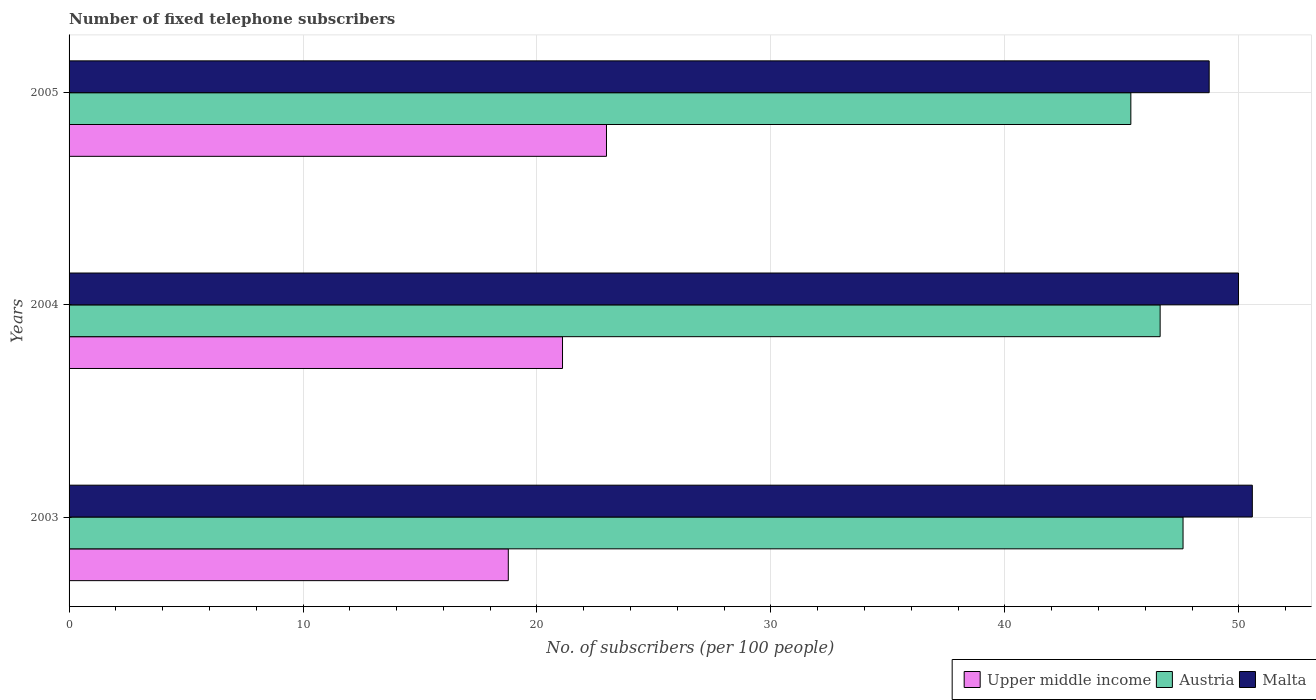How many different coloured bars are there?
Give a very brief answer. 3. How many bars are there on the 1st tick from the top?
Provide a short and direct response. 3. How many bars are there on the 1st tick from the bottom?
Your response must be concise. 3. What is the label of the 3rd group of bars from the top?
Offer a very short reply. 2003. In how many cases, is the number of bars for a given year not equal to the number of legend labels?
Keep it short and to the point. 0. What is the number of fixed telephone subscribers in Austria in 2005?
Your answer should be very brief. 45.38. Across all years, what is the maximum number of fixed telephone subscribers in Upper middle income?
Your answer should be very brief. 22.97. Across all years, what is the minimum number of fixed telephone subscribers in Upper middle income?
Your answer should be very brief. 18.77. In which year was the number of fixed telephone subscribers in Malta maximum?
Your response must be concise. 2003. In which year was the number of fixed telephone subscribers in Upper middle income minimum?
Ensure brevity in your answer.  2003. What is the total number of fixed telephone subscribers in Malta in the graph?
Your response must be concise. 149.3. What is the difference between the number of fixed telephone subscribers in Upper middle income in 2003 and that in 2004?
Offer a very short reply. -2.32. What is the difference between the number of fixed telephone subscribers in Austria in 2004 and the number of fixed telephone subscribers in Upper middle income in 2003?
Your answer should be very brief. 27.86. What is the average number of fixed telephone subscribers in Upper middle income per year?
Offer a terse response. 20.95. In the year 2003, what is the difference between the number of fixed telephone subscribers in Upper middle income and number of fixed telephone subscribers in Austria?
Give a very brief answer. -28.84. In how many years, is the number of fixed telephone subscribers in Upper middle income greater than 50 ?
Your response must be concise. 0. What is the ratio of the number of fixed telephone subscribers in Malta in 2003 to that in 2005?
Ensure brevity in your answer.  1.04. Is the number of fixed telephone subscribers in Malta in 2003 less than that in 2005?
Provide a short and direct response. No. Is the difference between the number of fixed telephone subscribers in Upper middle income in 2004 and 2005 greater than the difference between the number of fixed telephone subscribers in Austria in 2004 and 2005?
Give a very brief answer. No. What is the difference between the highest and the second highest number of fixed telephone subscribers in Austria?
Ensure brevity in your answer.  0.98. What is the difference between the highest and the lowest number of fixed telephone subscribers in Austria?
Ensure brevity in your answer.  2.23. What does the 2nd bar from the top in 2004 represents?
Ensure brevity in your answer.  Austria. What does the 1st bar from the bottom in 2004 represents?
Your response must be concise. Upper middle income. How many bars are there?
Offer a terse response. 9. How many years are there in the graph?
Ensure brevity in your answer.  3. What is the difference between two consecutive major ticks on the X-axis?
Offer a very short reply. 10. Does the graph contain any zero values?
Your answer should be very brief. No. Where does the legend appear in the graph?
Your response must be concise. Bottom right. How many legend labels are there?
Offer a terse response. 3. What is the title of the graph?
Provide a short and direct response. Number of fixed telephone subscribers. Does "European Union" appear as one of the legend labels in the graph?
Provide a short and direct response. No. What is the label or title of the X-axis?
Make the answer very short. No. of subscribers (per 100 people). What is the label or title of the Y-axis?
Provide a short and direct response. Years. What is the No. of subscribers (per 100 people) of Upper middle income in 2003?
Ensure brevity in your answer.  18.77. What is the No. of subscribers (per 100 people) of Austria in 2003?
Offer a very short reply. 47.62. What is the No. of subscribers (per 100 people) of Malta in 2003?
Your answer should be compact. 50.58. What is the No. of subscribers (per 100 people) in Upper middle income in 2004?
Provide a succinct answer. 21.09. What is the No. of subscribers (per 100 people) of Austria in 2004?
Offer a terse response. 46.64. What is the No. of subscribers (per 100 people) of Malta in 2004?
Make the answer very short. 49.99. What is the No. of subscribers (per 100 people) of Upper middle income in 2005?
Give a very brief answer. 22.97. What is the No. of subscribers (per 100 people) of Austria in 2005?
Provide a short and direct response. 45.38. What is the No. of subscribers (per 100 people) in Malta in 2005?
Provide a succinct answer. 48.73. Across all years, what is the maximum No. of subscribers (per 100 people) of Upper middle income?
Make the answer very short. 22.97. Across all years, what is the maximum No. of subscribers (per 100 people) in Austria?
Offer a terse response. 47.62. Across all years, what is the maximum No. of subscribers (per 100 people) of Malta?
Your answer should be very brief. 50.58. Across all years, what is the minimum No. of subscribers (per 100 people) in Upper middle income?
Give a very brief answer. 18.77. Across all years, what is the minimum No. of subscribers (per 100 people) in Austria?
Ensure brevity in your answer.  45.38. Across all years, what is the minimum No. of subscribers (per 100 people) in Malta?
Give a very brief answer. 48.73. What is the total No. of subscribers (per 100 people) of Upper middle income in the graph?
Your answer should be very brief. 62.84. What is the total No. of subscribers (per 100 people) of Austria in the graph?
Your answer should be very brief. 139.64. What is the total No. of subscribers (per 100 people) of Malta in the graph?
Your answer should be compact. 149.3. What is the difference between the No. of subscribers (per 100 people) of Upper middle income in 2003 and that in 2004?
Make the answer very short. -2.32. What is the difference between the No. of subscribers (per 100 people) in Austria in 2003 and that in 2004?
Give a very brief answer. 0.98. What is the difference between the No. of subscribers (per 100 people) of Malta in 2003 and that in 2004?
Your response must be concise. 0.59. What is the difference between the No. of subscribers (per 100 people) of Upper middle income in 2003 and that in 2005?
Give a very brief answer. -4.2. What is the difference between the No. of subscribers (per 100 people) of Austria in 2003 and that in 2005?
Make the answer very short. 2.23. What is the difference between the No. of subscribers (per 100 people) in Malta in 2003 and that in 2005?
Make the answer very short. 1.84. What is the difference between the No. of subscribers (per 100 people) of Upper middle income in 2004 and that in 2005?
Keep it short and to the point. -1.88. What is the difference between the No. of subscribers (per 100 people) in Austria in 2004 and that in 2005?
Ensure brevity in your answer.  1.25. What is the difference between the No. of subscribers (per 100 people) of Malta in 2004 and that in 2005?
Ensure brevity in your answer.  1.25. What is the difference between the No. of subscribers (per 100 people) of Upper middle income in 2003 and the No. of subscribers (per 100 people) of Austria in 2004?
Offer a very short reply. -27.86. What is the difference between the No. of subscribers (per 100 people) of Upper middle income in 2003 and the No. of subscribers (per 100 people) of Malta in 2004?
Provide a short and direct response. -31.21. What is the difference between the No. of subscribers (per 100 people) in Austria in 2003 and the No. of subscribers (per 100 people) in Malta in 2004?
Offer a very short reply. -2.37. What is the difference between the No. of subscribers (per 100 people) in Upper middle income in 2003 and the No. of subscribers (per 100 people) in Austria in 2005?
Your answer should be very brief. -26.61. What is the difference between the No. of subscribers (per 100 people) in Upper middle income in 2003 and the No. of subscribers (per 100 people) in Malta in 2005?
Make the answer very short. -29.96. What is the difference between the No. of subscribers (per 100 people) in Austria in 2003 and the No. of subscribers (per 100 people) in Malta in 2005?
Give a very brief answer. -1.12. What is the difference between the No. of subscribers (per 100 people) of Upper middle income in 2004 and the No. of subscribers (per 100 people) of Austria in 2005?
Your response must be concise. -24.29. What is the difference between the No. of subscribers (per 100 people) of Upper middle income in 2004 and the No. of subscribers (per 100 people) of Malta in 2005?
Your answer should be compact. -27.64. What is the difference between the No. of subscribers (per 100 people) of Austria in 2004 and the No. of subscribers (per 100 people) of Malta in 2005?
Your response must be concise. -2.1. What is the average No. of subscribers (per 100 people) in Upper middle income per year?
Give a very brief answer. 20.95. What is the average No. of subscribers (per 100 people) in Austria per year?
Provide a short and direct response. 46.55. What is the average No. of subscribers (per 100 people) of Malta per year?
Provide a short and direct response. 49.77. In the year 2003, what is the difference between the No. of subscribers (per 100 people) of Upper middle income and No. of subscribers (per 100 people) of Austria?
Give a very brief answer. -28.84. In the year 2003, what is the difference between the No. of subscribers (per 100 people) of Upper middle income and No. of subscribers (per 100 people) of Malta?
Make the answer very short. -31.8. In the year 2003, what is the difference between the No. of subscribers (per 100 people) of Austria and No. of subscribers (per 100 people) of Malta?
Provide a succinct answer. -2.96. In the year 2004, what is the difference between the No. of subscribers (per 100 people) in Upper middle income and No. of subscribers (per 100 people) in Austria?
Provide a succinct answer. -25.54. In the year 2004, what is the difference between the No. of subscribers (per 100 people) of Upper middle income and No. of subscribers (per 100 people) of Malta?
Offer a very short reply. -28.89. In the year 2004, what is the difference between the No. of subscribers (per 100 people) in Austria and No. of subscribers (per 100 people) in Malta?
Your answer should be very brief. -3.35. In the year 2005, what is the difference between the No. of subscribers (per 100 people) in Upper middle income and No. of subscribers (per 100 people) in Austria?
Your response must be concise. -22.41. In the year 2005, what is the difference between the No. of subscribers (per 100 people) of Upper middle income and No. of subscribers (per 100 people) of Malta?
Keep it short and to the point. -25.76. In the year 2005, what is the difference between the No. of subscribers (per 100 people) in Austria and No. of subscribers (per 100 people) in Malta?
Ensure brevity in your answer.  -3.35. What is the ratio of the No. of subscribers (per 100 people) in Upper middle income in 2003 to that in 2004?
Provide a short and direct response. 0.89. What is the ratio of the No. of subscribers (per 100 people) in Malta in 2003 to that in 2004?
Your answer should be very brief. 1.01. What is the ratio of the No. of subscribers (per 100 people) in Upper middle income in 2003 to that in 2005?
Ensure brevity in your answer.  0.82. What is the ratio of the No. of subscribers (per 100 people) in Austria in 2003 to that in 2005?
Your answer should be very brief. 1.05. What is the ratio of the No. of subscribers (per 100 people) of Malta in 2003 to that in 2005?
Your response must be concise. 1.04. What is the ratio of the No. of subscribers (per 100 people) of Upper middle income in 2004 to that in 2005?
Make the answer very short. 0.92. What is the ratio of the No. of subscribers (per 100 people) of Austria in 2004 to that in 2005?
Ensure brevity in your answer.  1.03. What is the ratio of the No. of subscribers (per 100 people) of Malta in 2004 to that in 2005?
Provide a succinct answer. 1.03. What is the difference between the highest and the second highest No. of subscribers (per 100 people) of Upper middle income?
Your answer should be very brief. 1.88. What is the difference between the highest and the second highest No. of subscribers (per 100 people) in Austria?
Offer a very short reply. 0.98. What is the difference between the highest and the second highest No. of subscribers (per 100 people) in Malta?
Provide a succinct answer. 0.59. What is the difference between the highest and the lowest No. of subscribers (per 100 people) of Upper middle income?
Offer a very short reply. 4.2. What is the difference between the highest and the lowest No. of subscribers (per 100 people) in Austria?
Your answer should be very brief. 2.23. What is the difference between the highest and the lowest No. of subscribers (per 100 people) of Malta?
Provide a succinct answer. 1.84. 